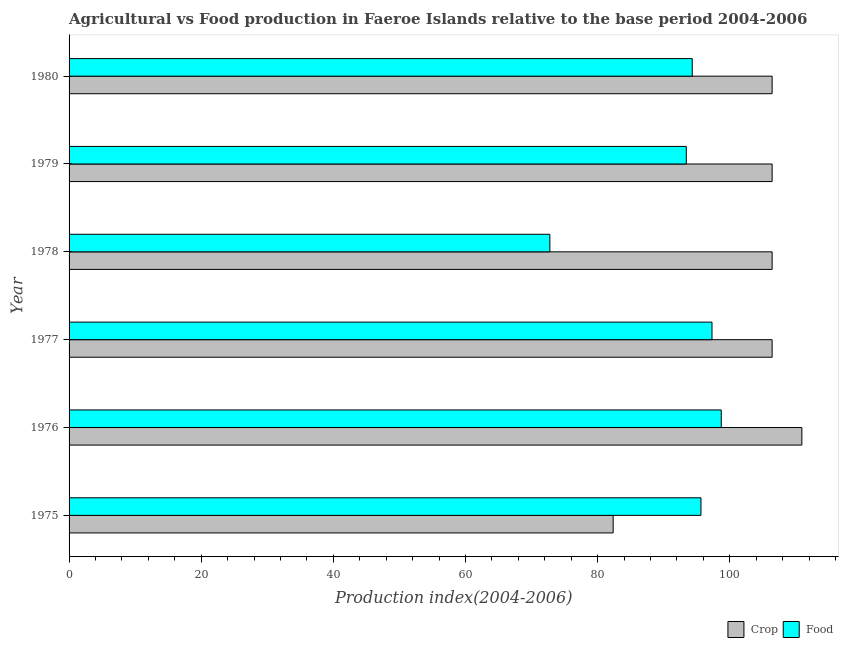How many different coloured bars are there?
Your response must be concise. 2. How many groups of bars are there?
Your answer should be compact. 6. How many bars are there on the 2nd tick from the top?
Provide a succinct answer. 2. What is the label of the 3rd group of bars from the top?
Provide a succinct answer. 1978. What is the crop production index in 1980?
Offer a terse response. 106.41. Across all years, what is the maximum food production index?
Give a very brief answer. 98.71. Across all years, what is the minimum food production index?
Provide a short and direct response. 72.77. In which year was the food production index maximum?
Make the answer very short. 1976. In which year was the crop production index minimum?
Your response must be concise. 1975. What is the total crop production index in the graph?
Your response must be concise. 618.9. What is the difference between the crop production index in 1975 and that in 1977?
Your answer should be compact. -24.06. What is the difference between the crop production index in 1980 and the food production index in 1977?
Your answer should be very brief. 9.1. What is the average food production index per year?
Keep it short and to the point. 92.03. In the year 1978, what is the difference between the food production index and crop production index?
Your answer should be compact. -33.64. In how many years, is the food production index greater than 112 ?
Provide a succinct answer. 0. What is the ratio of the food production index in 1975 to that in 1978?
Make the answer very short. 1.31. Is the food production index in 1975 less than that in 1978?
Provide a short and direct response. No. Is the difference between the crop production index in 1976 and 1979 greater than the difference between the food production index in 1976 and 1979?
Ensure brevity in your answer.  No. What is the difference between the highest and the lowest crop production index?
Your answer should be compact. 28.56. In how many years, is the food production index greater than the average food production index taken over all years?
Your answer should be very brief. 5. What does the 2nd bar from the top in 1976 represents?
Make the answer very short. Crop. What does the 2nd bar from the bottom in 1975 represents?
Your answer should be compact. Food. Are all the bars in the graph horizontal?
Offer a very short reply. Yes. Does the graph contain any zero values?
Your answer should be compact. No. What is the title of the graph?
Your answer should be very brief. Agricultural vs Food production in Faeroe Islands relative to the base period 2004-2006. Does "Personal remittances" appear as one of the legend labels in the graph?
Offer a very short reply. No. What is the label or title of the X-axis?
Ensure brevity in your answer.  Production index(2004-2006). What is the Production index(2004-2006) in Crop in 1975?
Make the answer very short. 82.35. What is the Production index(2004-2006) of Food in 1975?
Give a very brief answer. 95.64. What is the Production index(2004-2006) in Crop in 1976?
Your answer should be compact. 110.91. What is the Production index(2004-2006) of Food in 1976?
Provide a succinct answer. 98.71. What is the Production index(2004-2006) of Crop in 1977?
Ensure brevity in your answer.  106.41. What is the Production index(2004-2006) in Food in 1977?
Make the answer very short. 97.31. What is the Production index(2004-2006) of Crop in 1978?
Ensure brevity in your answer.  106.41. What is the Production index(2004-2006) of Food in 1978?
Make the answer very short. 72.77. What is the Production index(2004-2006) of Crop in 1979?
Ensure brevity in your answer.  106.41. What is the Production index(2004-2006) in Food in 1979?
Give a very brief answer. 93.42. What is the Production index(2004-2006) of Crop in 1980?
Your answer should be very brief. 106.41. What is the Production index(2004-2006) of Food in 1980?
Offer a very short reply. 94.32. Across all years, what is the maximum Production index(2004-2006) in Crop?
Provide a short and direct response. 110.91. Across all years, what is the maximum Production index(2004-2006) of Food?
Ensure brevity in your answer.  98.71. Across all years, what is the minimum Production index(2004-2006) of Crop?
Give a very brief answer. 82.35. Across all years, what is the minimum Production index(2004-2006) of Food?
Ensure brevity in your answer.  72.77. What is the total Production index(2004-2006) in Crop in the graph?
Your answer should be compact. 618.9. What is the total Production index(2004-2006) of Food in the graph?
Your answer should be very brief. 552.17. What is the difference between the Production index(2004-2006) of Crop in 1975 and that in 1976?
Your answer should be very brief. -28.56. What is the difference between the Production index(2004-2006) in Food in 1975 and that in 1976?
Make the answer very short. -3.07. What is the difference between the Production index(2004-2006) of Crop in 1975 and that in 1977?
Keep it short and to the point. -24.06. What is the difference between the Production index(2004-2006) in Food in 1975 and that in 1977?
Offer a very short reply. -1.67. What is the difference between the Production index(2004-2006) in Crop in 1975 and that in 1978?
Offer a very short reply. -24.06. What is the difference between the Production index(2004-2006) of Food in 1975 and that in 1978?
Offer a terse response. 22.87. What is the difference between the Production index(2004-2006) of Crop in 1975 and that in 1979?
Provide a short and direct response. -24.06. What is the difference between the Production index(2004-2006) in Food in 1975 and that in 1979?
Ensure brevity in your answer.  2.22. What is the difference between the Production index(2004-2006) in Crop in 1975 and that in 1980?
Offer a very short reply. -24.06. What is the difference between the Production index(2004-2006) in Food in 1975 and that in 1980?
Your answer should be compact. 1.32. What is the difference between the Production index(2004-2006) in Crop in 1976 and that in 1977?
Provide a succinct answer. 4.5. What is the difference between the Production index(2004-2006) of Crop in 1976 and that in 1978?
Provide a short and direct response. 4.5. What is the difference between the Production index(2004-2006) of Food in 1976 and that in 1978?
Keep it short and to the point. 25.94. What is the difference between the Production index(2004-2006) of Food in 1976 and that in 1979?
Offer a very short reply. 5.29. What is the difference between the Production index(2004-2006) in Crop in 1976 and that in 1980?
Give a very brief answer. 4.5. What is the difference between the Production index(2004-2006) in Food in 1976 and that in 1980?
Your answer should be very brief. 4.39. What is the difference between the Production index(2004-2006) of Crop in 1977 and that in 1978?
Your answer should be very brief. 0. What is the difference between the Production index(2004-2006) in Food in 1977 and that in 1978?
Your answer should be very brief. 24.54. What is the difference between the Production index(2004-2006) of Crop in 1977 and that in 1979?
Your answer should be compact. 0. What is the difference between the Production index(2004-2006) of Food in 1977 and that in 1979?
Keep it short and to the point. 3.89. What is the difference between the Production index(2004-2006) in Food in 1977 and that in 1980?
Provide a succinct answer. 2.99. What is the difference between the Production index(2004-2006) in Food in 1978 and that in 1979?
Make the answer very short. -20.65. What is the difference between the Production index(2004-2006) of Food in 1978 and that in 1980?
Keep it short and to the point. -21.55. What is the difference between the Production index(2004-2006) in Crop in 1979 and that in 1980?
Ensure brevity in your answer.  0. What is the difference between the Production index(2004-2006) in Food in 1979 and that in 1980?
Give a very brief answer. -0.9. What is the difference between the Production index(2004-2006) of Crop in 1975 and the Production index(2004-2006) of Food in 1976?
Provide a short and direct response. -16.36. What is the difference between the Production index(2004-2006) of Crop in 1975 and the Production index(2004-2006) of Food in 1977?
Your answer should be compact. -14.96. What is the difference between the Production index(2004-2006) in Crop in 1975 and the Production index(2004-2006) in Food in 1978?
Provide a succinct answer. 9.58. What is the difference between the Production index(2004-2006) in Crop in 1975 and the Production index(2004-2006) in Food in 1979?
Ensure brevity in your answer.  -11.07. What is the difference between the Production index(2004-2006) in Crop in 1975 and the Production index(2004-2006) in Food in 1980?
Keep it short and to the point. -11.97. What is the difference between the Production index(2004-2006) in Crop in 1976 and the Production index(2004-2006) in Food in 1977?
Offer a terse response. 13.6. What is the difference between the Production index(2004-2006) of Crop in 1976 and the Production index(2004-2006) of Food in 1978?
Your response must be concise. 38.14. What is the difference between the Production index(2004-2006) in Crop in 1976 and the Production index(2004-2006) in Food in 1979?
Provide a succinct answer. 17.49. What is the difference between the Production index(2004-2006) in Crop in 1976 and the Production index(2004-2006) in Food in 1980?
Ensure brevity in your answer.  16.59. What is the difference between the Production index(2004-2006) in Crop in 1977 and the Production index(2004-2006) in Food in 1978?
Keep it short and to the point. 33.64. What is the difference between the Production index(2004-2006) in Crop in 1977 and the Production index(2004-2006) in Food in 1979?
Ensure brevity in your answer.  12.99. What is the difference between the Production index(2004-2006) in Crop in 1977 and the Production index(2004-2006) in Food in 1980?
Ensure brevity in your answer.  12.09. What is the difference between the Production index(2004-2006) in Crop in 1978 and the Production index(2004-2006) in Food in 1979?
Provide a short and direct response. 12.99. What is the difference between the Production index(2004-2006) of Crop in 1978 and the Production index(2004-2006) of Food in 1980?
Ensure brevity in your answer.  12.09. What is the difference between the Production index(2004-2006) in Crop in 1979 and the Production index(2004-2006) in Food in 1980?
Your answer should be compact. 12.09. What is the average Production index(2004-2006) of Crop per year?
Ensure brevity in your answer.  103.15. What is the average Production index(2004-2006) in Food per year?
Offer a terse response. 92.03. In the year 1975, what is the difference between the Production index(2004-2006) of Crop and Production index(2004-2006) of Food?
Provide a short and direct response. -13.29. In the year 1978, what is the difference between the Production index(2004-2006) of Crop and Production index(2004-2006) of Food?
Give a very brief answer. 33.64. In the year 1979, what is the difference between the Production index(2004-2006) in Crop and Production index(2004-2006) in Food?
Provide a succinct answer. 12.99. In the year 1980, what is the difference between the Production index(2004-2006) of Crop and Production index(2004-2006) of Food?
Provide a succinct answer. 12.09. What is the ratio of the Production index(2004-2006) of Crop in 1975 to that in 1976?
Provide a short and direct response. 0.74. What is the ratio of the Production index(2004-2006) in Food in 1975 to that in 1976?
Give a very brief answer. 0.97. What is the ratio of the Production index(2004-2006) of Crop in 1975 to that in 1977?
Ensure brevity in your answer.  0.77. What is the ratio of the Production index(2004-2006) in Food in 1975 to that in 1977?
Your response must be concise. 0.98. What is the ratio of the Production index(2004-2006) in Crop in 1975 to that in 1978?
Your response must be concise. 0.77. What is the ratio of the Production index(2004-2006) in Food in 1975 to that in 1978?
Offer a terse response. 1.31. What is the ratio of the Production index(2004-2006) in Crop in 1975 to that in 1979?
Provide a short and direct response. 0.77. What is the ratio of the Production index(2004-2006) in Food in 1975 to that in 1979?
Make the answer very short. 1.02. What is the ratio of the Production index(2004-2006) of Crop in 1975 to that in 1980?
Provide a short and direct response. 0.77. What is the ratio of the Production index(2004-2006) in Crop in 1976 to that in 1977?
Offer a terse response. 1.04. What is the ratio of the Production index(2004-2006) of Food in 1976 to that in 1977?
Make the answer very short. 1.01. What is the ratio of the Production index(2004-2006) of Crop in 1976 to that in 1978?
Give a very brief answer. 1.04. What is the ratio of the Production index(2004-2006) of Food in 1976 to that in 1978?
Offer a very short reply. 1.36. What is the ratio of the Production index(2004-2006) of Crop in 1976 to that in 1979?
Your answer should be compact. 1.04. What is the ratio of the Production index(2004-2006) in Food in 1976 to that in 1979?
Make the answer very short. 1.06. What is the ratio of the Production index(2004-2006) in Crop in 1976 to that in 1980?
Provide a short and direct response. 1.04. What is the ratio of the Production index(2004-2006) in Food in 1976 to that in 1980?
Your answer should be very brief. 1.05. What is the ratio of the Production index(2004-2006) of Food in 1977 to that in 1978?
Ensure brevity in your answer.  1.34. What is the ratio of the Production index(2004-2006) of Crop in 1977 to that in 1979?
Provide a succinct answer. 1. What is the ratio of the Production index(2004-2006) of Food in 1977 to that in 1979?
Provide a short and direct response. 1.04. What is the ratio of the Production index(2004-2006) in Food in 1977 to that in 1980?
Give a very brief answer. 1.03. What is the ratio of the Production index(2004-2006) of Food in 1978 to that in 1979?
Your answer should be very brief. 0.78. What is the ratio of the Production index(2004-2006) of Crop in 1978 to that in 1980?
Make the answer very short. 1. What is the ratio of the Production index(2004-2006) of Food in 1978 to that in 1980?
Give a very brief answer. 0.77. What is the difference between the highest and the second highest Production index(2004-2006) of Crop?
Provide a short and direct response. 4.5. What is the difference between the highest and the lowest Production index(2004-2006) in Crop?
Make the answer very short. 28.56. What is the difference between the highest and the lowest Production index(2004-2006) of Food?
Offer a very short reply. 25.94. 